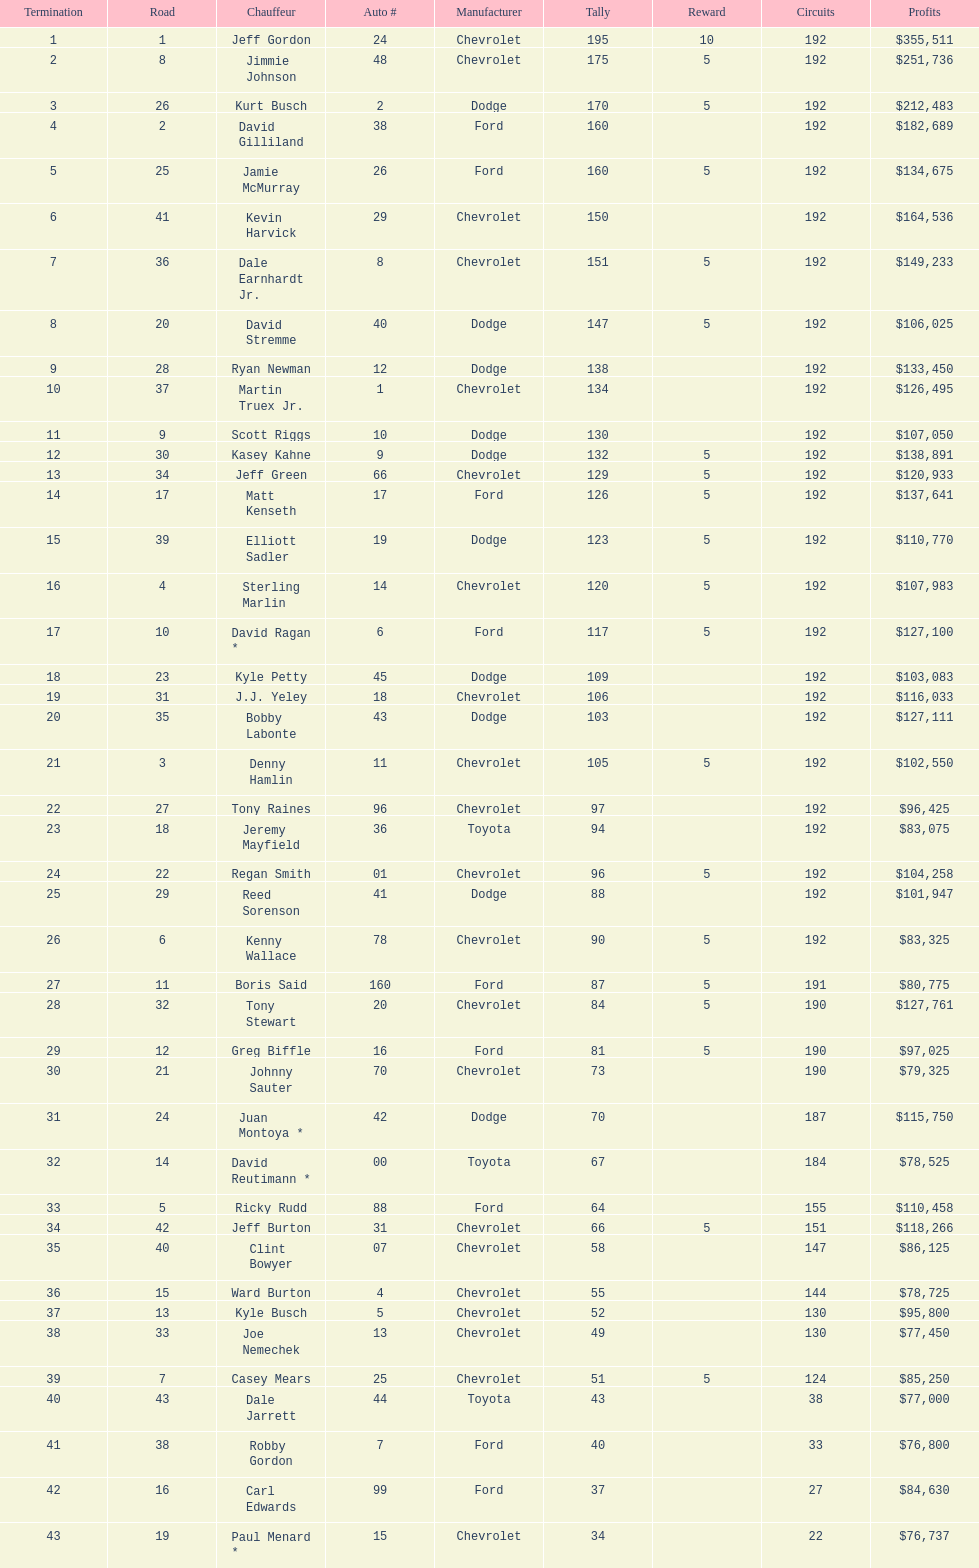Could you parse the entire table as a dict? {'header': ['Termination', 'Road', 'Chauffeur', 'Auto #', 'Manufacturer', 'Tally', 'Reward', 'Circuits', 'Profits'], 'rows': [['1', '1', 'Jeff Gordon', '24', 'Chevrolet', '195', '10', '192', '$355,511'], ['2', '8', 'Jimmie Johnson', '48', 'Chevrolet', '175', '5', '192', '$251,736'], ['3', '26', 'Kurt Busch', '2', 'Dodge', '170', '5', '192', '$212,483'], ['4', '2', 'David Gilliland', '38', 'Ford', '160', '', '192', '$182,689'], ['5', '25', 'Jamie McMurray', '26', 'Ford', '160', '5', '192', '$134,675'], ['6', '41', 'Kevin Harvick', '29', 'Chevrolet', '150', '', '192', '$164,536'], ['7', '36', 'Dale Earnhardt Jr.', '8', 'Chevrolet', '151', '5', '192', '$149,233'], ['8', '20', 'David Stremme', '40', 'Dodge', '147', '5', '192', '$106,025'], ['9', '28', 'Ryan Newman', '12', 'Dodge', '138', '', '192', '$133,450'], ['10', '37', 'Martin Truex Jr.', '1', 'Chevrolet', '134', '', '192', '$126,495'], ['11', '9', 'Scott Riggs', '10', 'Dodge', '130', '', '192', '$107,050'], ['12', '30', 'Kasey Kahne', '9', 'Dodge', '132', '5', '192', '$138,891'], ['13', '34', 'Jeff Green', '66', 'Chevrolet', '129', '5', '192', '$120,933'], ['14', '17', 'Matt Kenseth', '17', 'Ford', '126', '5', '192', '$137,641'], ['15', '39', 'Elliott Sadler', '19', 'Dodge', '123', '5', '192', '$110,770'], ['16', '4', 'Sterling Marlin', '14', 'Chevrolet', '120', '5', '192', '$107,983'], ['17', '10', 'David Ragan *', '6', 'Ford', '117', '5', '192', '$127,100'], ['18', '23', 'Kyle Petty', '45', 'Dodge', '109', '', '192', '$103,083'], ['19', '31', 'J.J. Yeley', '18', 'Chevrolet', '106', '', '192', '$116,033'], ['20', '35', 'Bobby Labonte', '43', 'Dodge', '103', '', '192', '$127,111'], ['21', '3', 'Denny Hamlin', '11', 'Chevrolet', '105', '5', '192', '$102,550'], ['22', '27', 'Tony Raines', '96', 'Chevrolet', '97', '', '192', '$96,425'], ['23', '18', 'Jeremy Mayfield', '36', 'Toyota', '94', '', '192', '$83,075'], ['24', '22', 'Regan Smith', '01', 'Chevrolet', '96', '5', '192', '$104,258'], ['25', '29', 'Reed Sorenson', '41', 'Dodge', '88', '', '192', '$101,947'], ['26', '6', 'Kenny Wallace', '78', 'Chevrolet', '90', '5', '192', '$83,325'], ['27', '11', 'Boris Said', '160', 'Ford', '87', '5', '191', '$80,775'], ['28', '32', 'Tony Stewart', '20', 'Chevrolet', '84', '5', '190', '$127,761'], ['29', '12', 'Greg Biffle', '16', 'Ford', '81', '5', '190', '$97,025'], ['30', '21', 'Johnny Sauter', '70', 'Chevrolet', '73', '', '190', '$79,325'], ['31', '24', 'Juan Montoya *', '42', 'Dodge', '70', '', '187', '$115,750'], ['32', '14', 'David Reutimann *', '00', 'Toyota', '67', '', '184', '$78,525'], ['33', '5', 'Ricky Rudd', '88', 'Ford', '64', '', '155', '$110,458'], ['34', '42', 'Jeff Burton', '31', 'Chevrolet', '66', '5', '151', '$118,266'], ['35', '40', 'Clint Bowyer', '07', 'Chevrolet', '58', '', '147', '$86,125'], ['36', '15', 'Ward Burton', '4', 'Chevrolet', '55', '', '144', '$78,725'], ['37', '13', 'Kyle Busch', '5', 'Chevrolet', '52', '', '130', '$95,800'], ['38', '33', 'Joe Nemechek', '13', 'Chevrolet', '49', '', '130', '$77,450'], ['39', '7', 'Casey Mears', '25', 'Chevrolet', '51', '5', '124', '$85,250'], ['40', '43', 'Dale Jarrett', '44', 'Toyota', '43', '', '38', '$77,000'], ['41', '38', 'Robby Gordon', '7', 'Ford', '40', '', '33', '$76,800'], ['42', '16', 'Carl Edwards', '99', 'Ford', '37', '', '27', '$84,630'], ['43', '19', 'Paul Menard *', '15', 'Chevrolet', '34', '', '22', '$76,737']]} Who got the most bonus points? Jeff Gordon. 